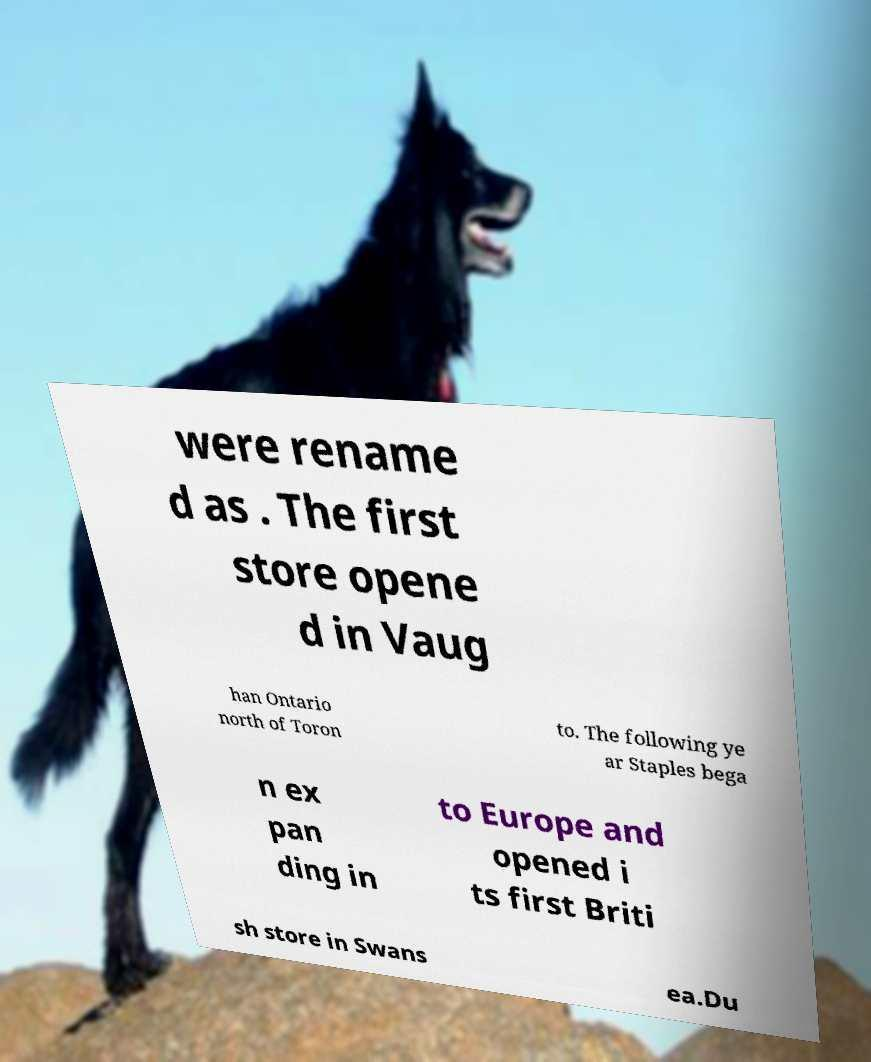What messages or text are displayed in this image? I need them in a readable, typed format. were rename d as . The first store opene d in Vaug han Ontario north of Toron to. The following ye ar Staples bega n ex pan ding in to Europe and opened i ts first Briti sh store in Swans ea.Du 